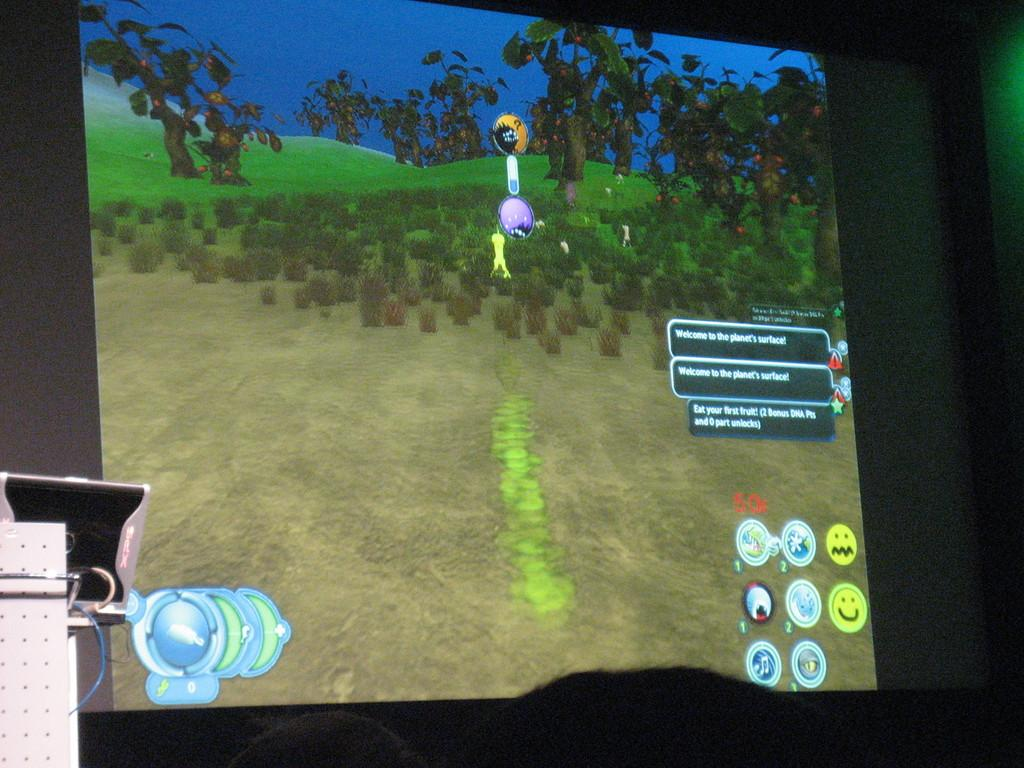What is the main object in the image? There is a projector screen in the image. What is being displayed on the projector screen? A cartoon is displayed on the screen. What elements can be seen in the cartoon? The cartoon features trees and grass. How far away is the tank from the projector screen in the image? There is no tank present in the image, so it is not possible to determine the distance between a tank and the projector screen. 